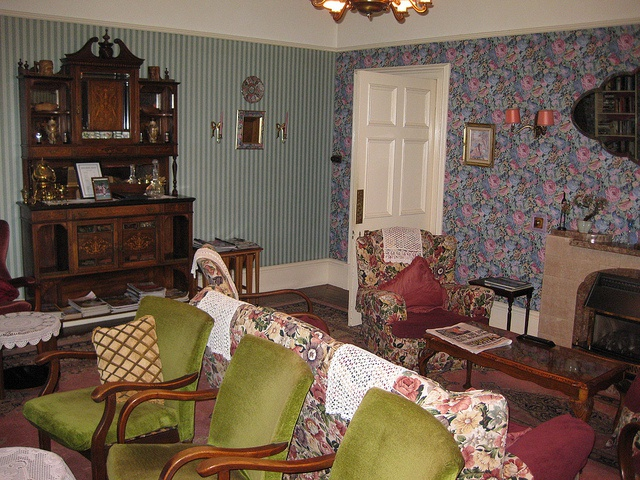Describe the objects in this image and their specific colors. I can see couch in gray, lightgray, tan, brown, and darkgray tones, chair in gray, olive, and maroon tones, chair in gray, olive, black, and maroon tones, chair in gray, maroon, and black tones, and chair in gray, olive, and maroon tones in this image. 